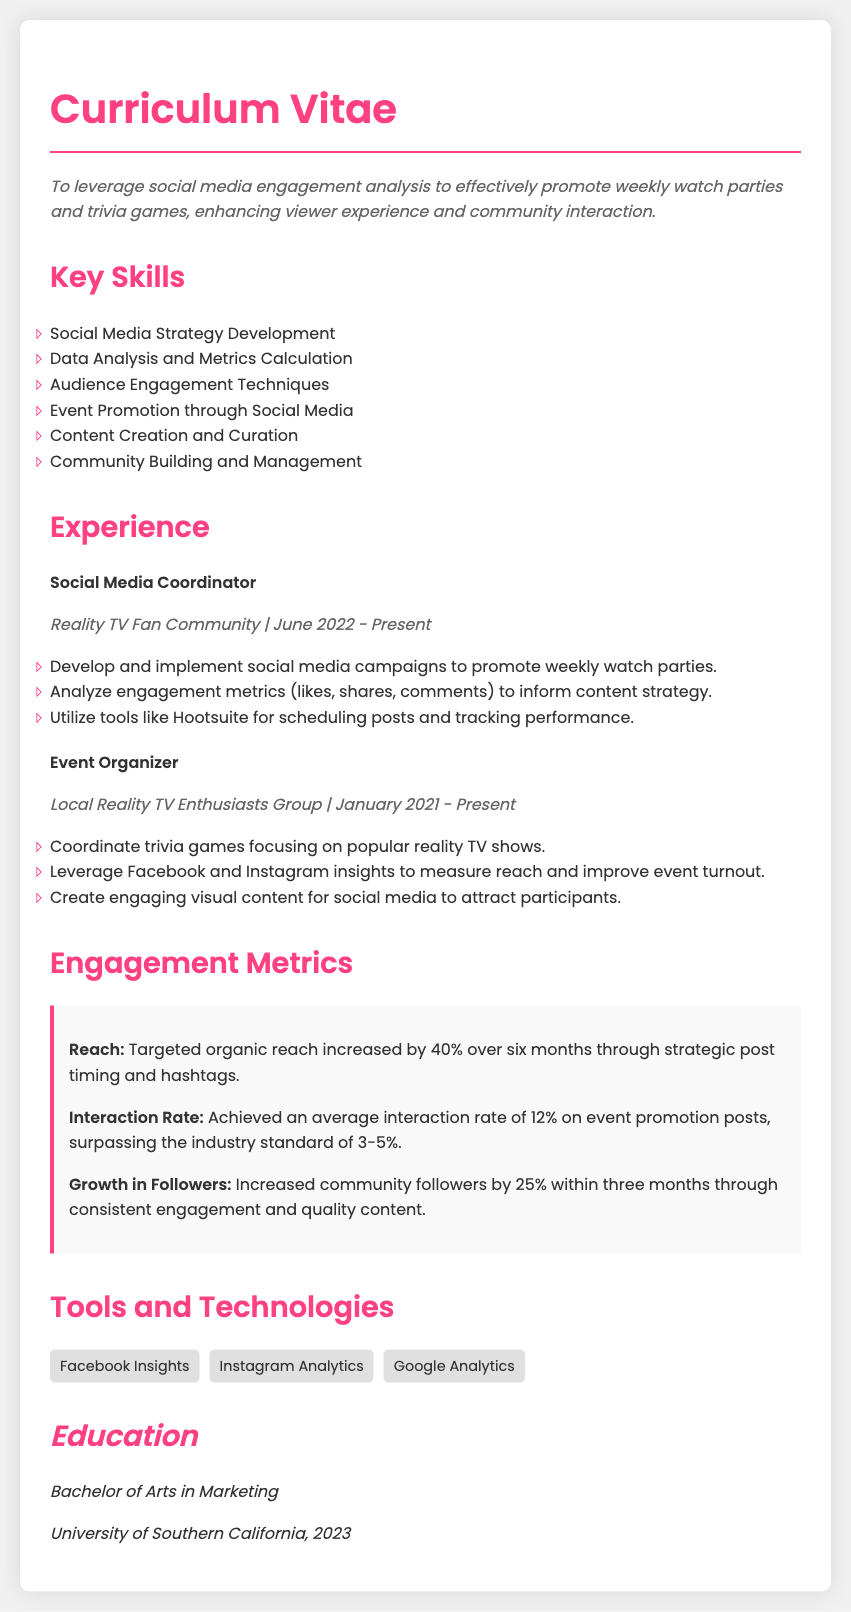What is the job title of the individual? The job title is listed under the work experience section as "Social Media Coordinator."
Answer: Social Media Coordinator When did the individual start working as an Event Organizer? The start date for the Event Organizer role is mentioned in the experience section as "January 2021."
Answer: January 2021 What percentage did the targeted organic reach increase? The percentage increase is specified in the engagement metrics as "40%."
Answer: 40% What is the average interaction rate achieved on event promotion posts? The average interaction rate mentioned in the metrics is "12%," which is above the industry standard.
Answer: 12% How many followers did the community increase within three months? The growth in followers is detailed in the metrics as an increase of "25%."
Answer: 25% Which social media tools are mentioned for analytics? The tools listed in the document include "Facebook Insights," "Instagram Analytics," and "Google Analytics."
Answer: Facebook Insights, Instagram Analytics, Google Analytics What degree did the individual earn? The degree is specified in the education section as "Bachelor of Arts in Marketing."
Answer: Bachelor of Arts in Marketing What was the role of the individual at Reality TV Fan Community? The role is identified in the experience section as "Social Media Coordinator."
Answer: Social Media Coordinator What color is used for the section headings in the document? The color used for the section headings is described in the styling as "#ff4081."
Answer: #ff4081 